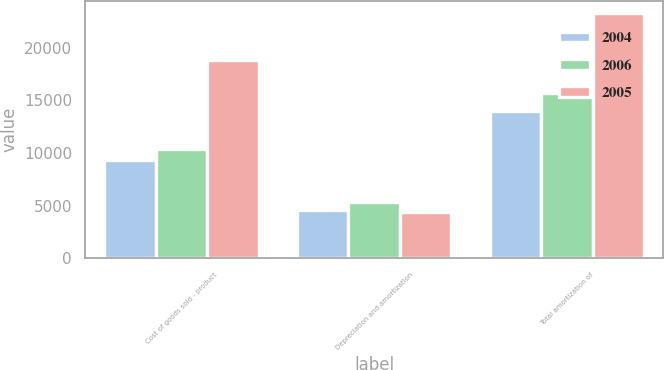Convert chart. <chart><loc_0><loc_0><loc_500><loc_500><stacked_bar_chart><ecel><fcel>Cost of goods sold - product<fcel>Depreciation and amortization<fcel>Total amortization of<nl><fcel>2004<fcel>9372<fcel>4628<fcel>14000<nl><fcel>2006<fcel>10364<fcel>5365<fcel>15729<nl><fcel>2005<fcel>18870<fcel>4403<fcel>23273<nl></chart> 